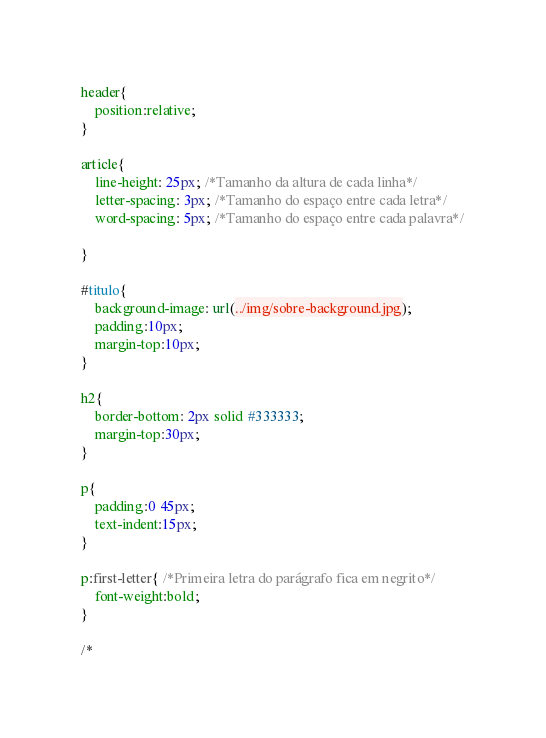<code> <loc_0><loc_0><loc_500><loc_500><_CSS_>header{
    position:relative;
}

article{
    line-height: 25px; /*Tamanho da altura de cada linha*/
    letter-spacing: 3px; /*Tamanho do espaço entre cada letra*/
    word-spacing: 5px; /*Tamanho do espaço entre cada palavra*/

}

#titulo{
    background-image: url(../img/sobre-background.jpg);
    padding:10px;
    margin-top:10px;
}

h2{
    border-bottom: 2px solid #333333;
    margin-top:30px;
}

p{
    padding:0 45px;
    text-indent:15px;
}

p:first-letter{ /*Primeira letra do parágrafo fica em negrito*/
    font-weight:bold;
}

/*</code> 